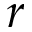<formula> <loc_0><loc_0><loc_500><loc_500>r</formula> 